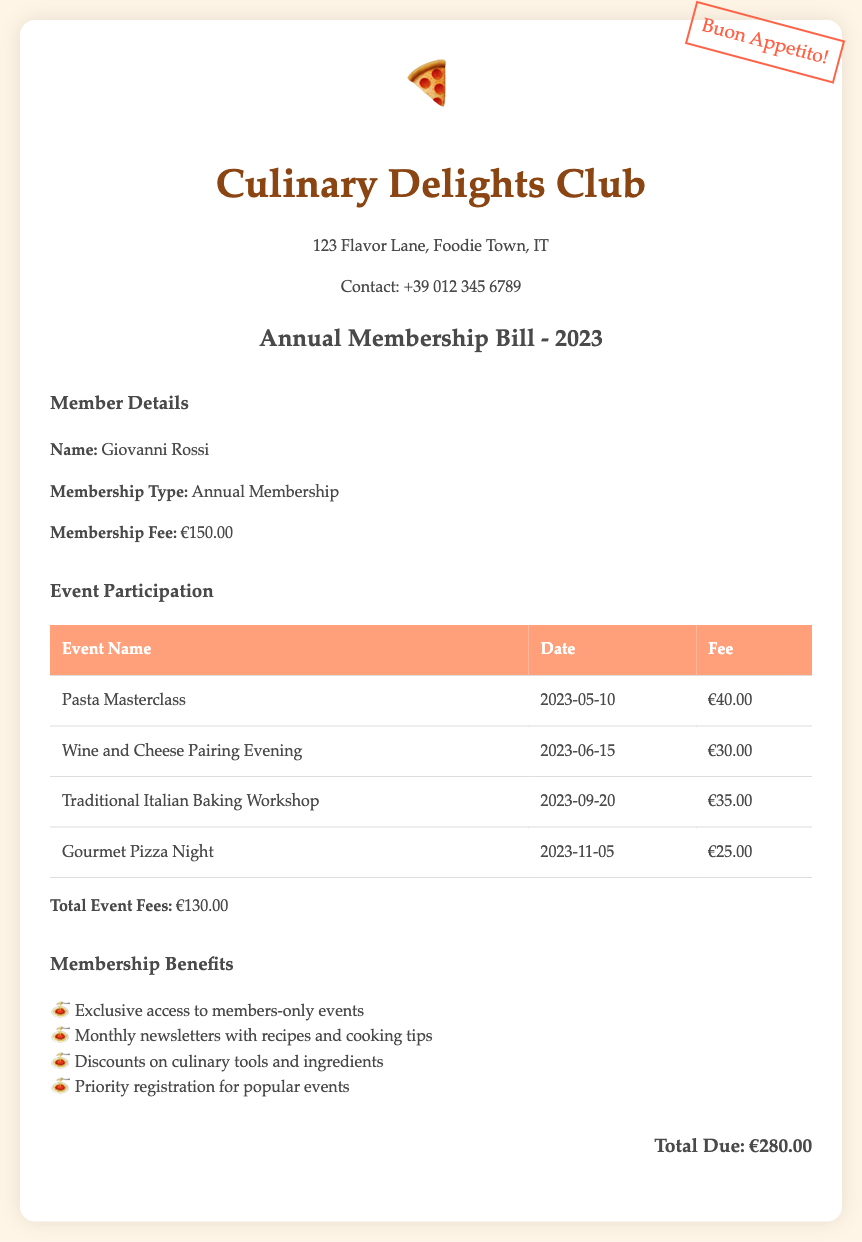What is the name of the member? The document provides the member's name in the member details section as "Giovanni Rossi."
Answer: Giovanni Rossi What is the date of the Gourmet Pizza Night? The event's date is specified in the events table as November 5, 2023.
Answer: 2023-11-05 What is the total due amount for the membership and events? The total due is calculated based on the membership fee and total event fees, listed as €280.00.
Answer: €280.00 How much is the membership fee? The membership fee is explicitly stated in the member details section as €150.00.
Answer: €150.00 What is the fee for the Wine and Cheese Pairing Evening? The document lists the fee for this event in the events table, which is €30.00.
Answer: €30.00 How many benefits does membership offer? The benefits section includes four distinct benefits listed in the document.
Answer: 4 What is the total amount paid for events? The total event fees are summarized in the events section as €130.00.
Answer: €130.00 Which event has the highest participation fee? The Pasta Masterclass is indicated as having the highest fee of €40.00.
Answer: €40.00 What type of membership is listed? The membership type is described as "Annual Membership" in the member details section.
Answer: Annual Membership 